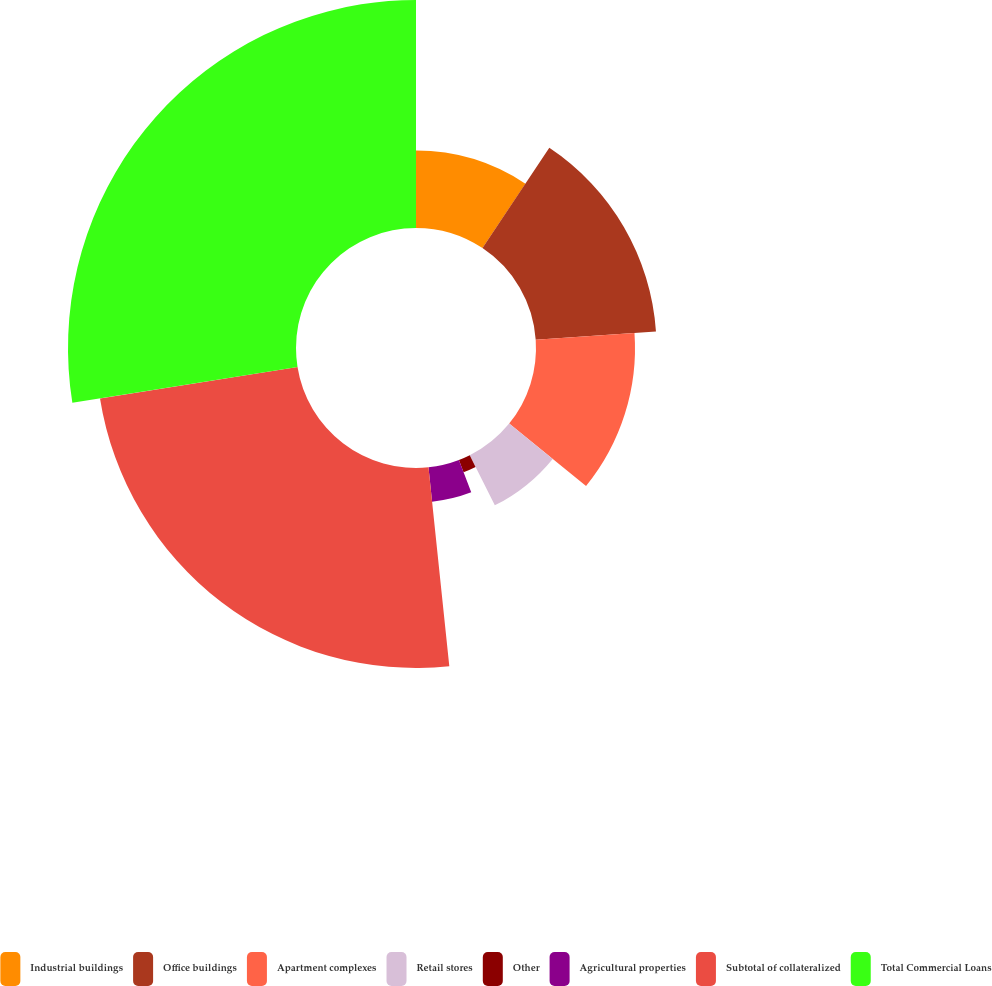Convert chart to OTSL. <chart><loc_0><loc_0><loc_500><loc_500><pie_chart><fcel>Industrial buildings<fcel>Office buildings<fcel>Apartment complexes<fcel>Retail stores<fcel>Other<fcel>Agricultural properties<fcel>Subtotal of collateralized<fcel>Total Commercial Loans<nl><fcel>9.35%<fcel>14.55%<fcel>11.95%<fcel>6.76%<fcel>1.57%<fcel>4.16%<fcel>24.14%<fcel>27.52%<nl></chart> 